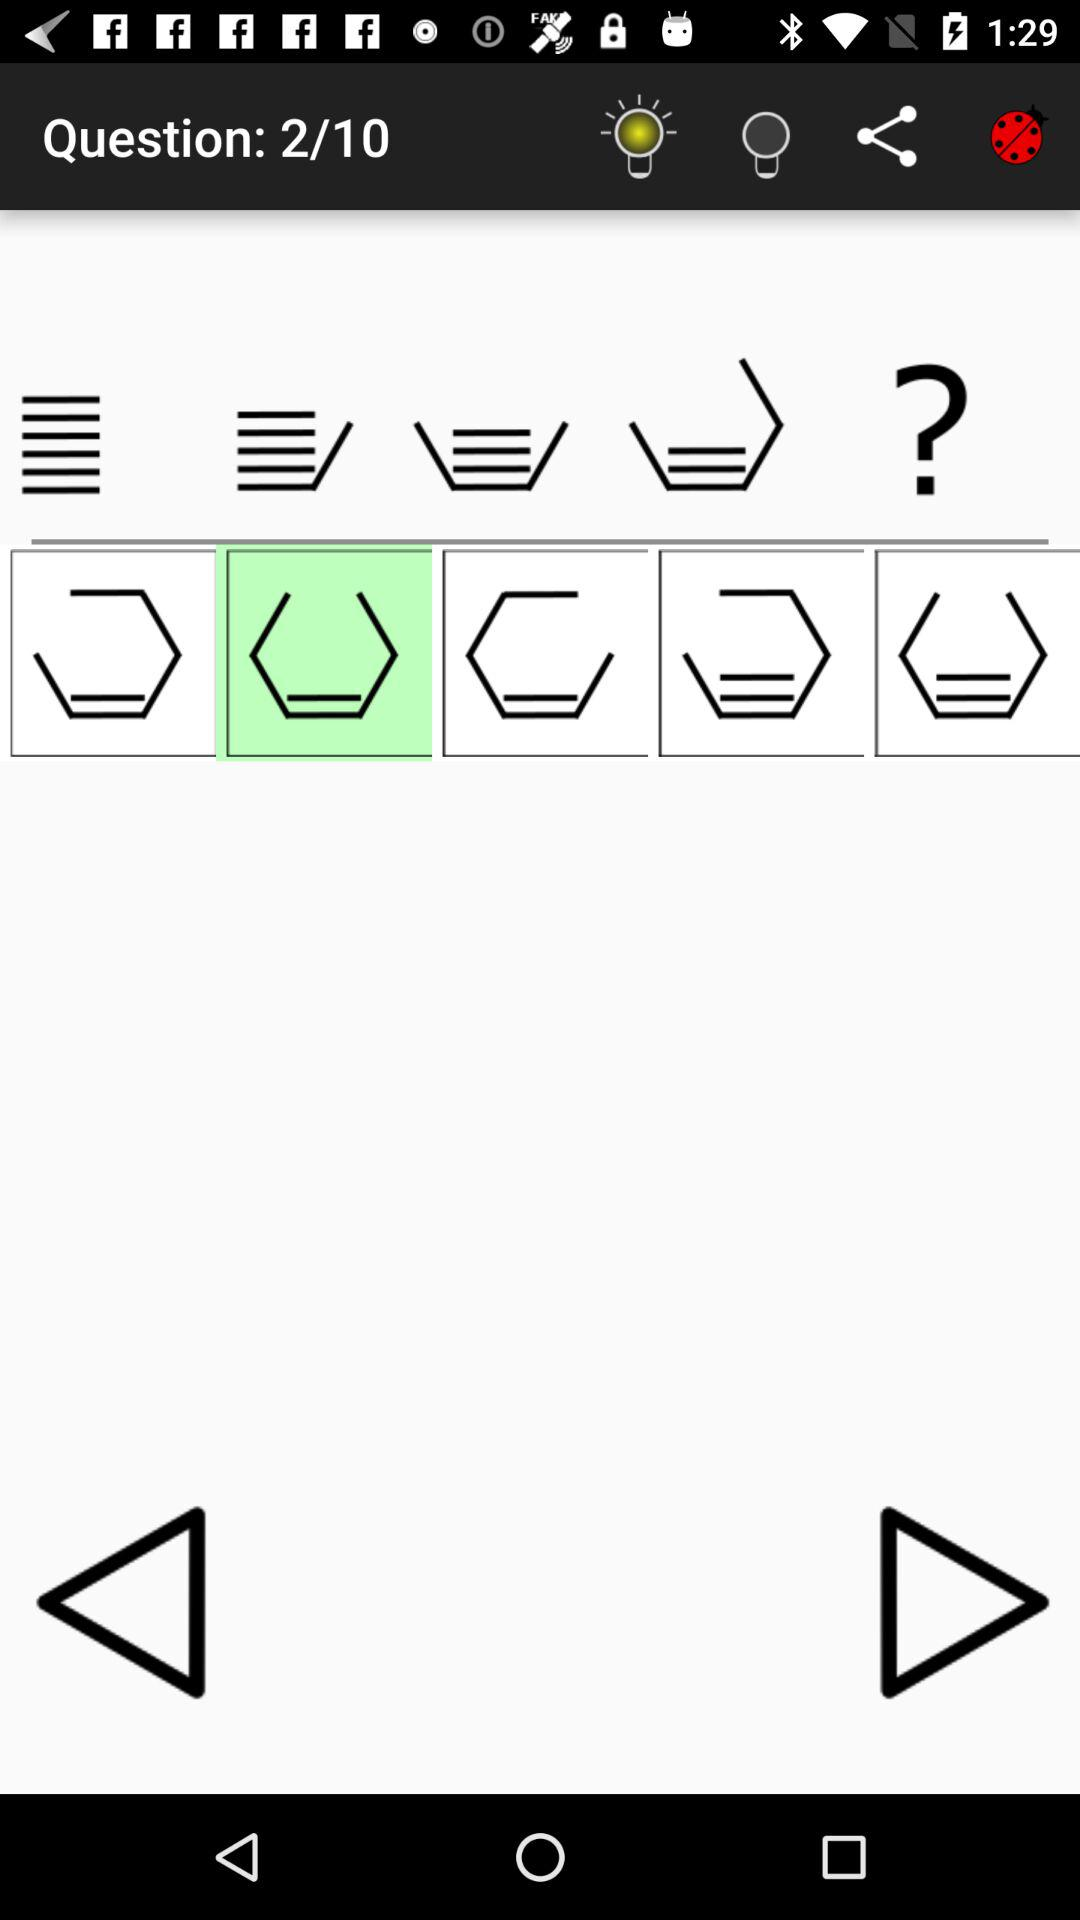What is the current question number shown on the screen? The current question number is 2. 